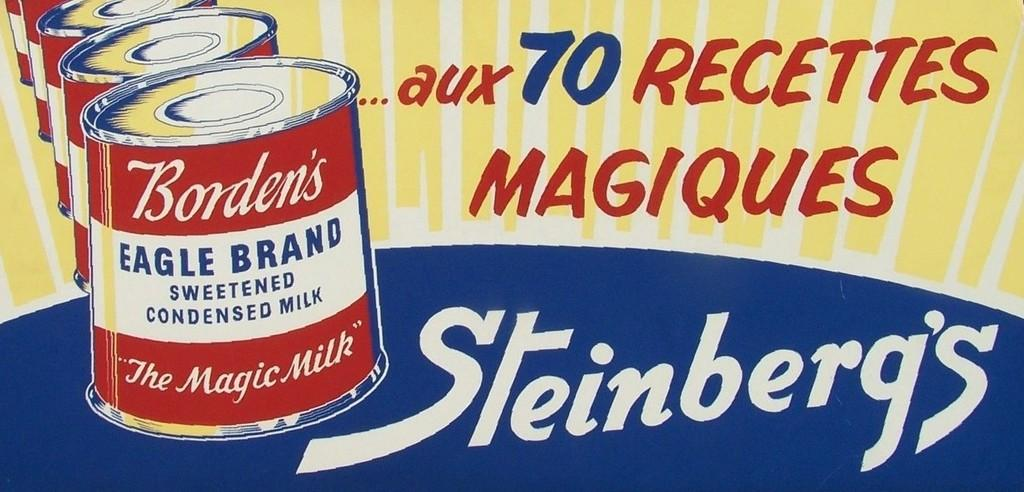<image>
Provide a brief description of the given image. some cans that say steinberg's on it with a cartoon image 